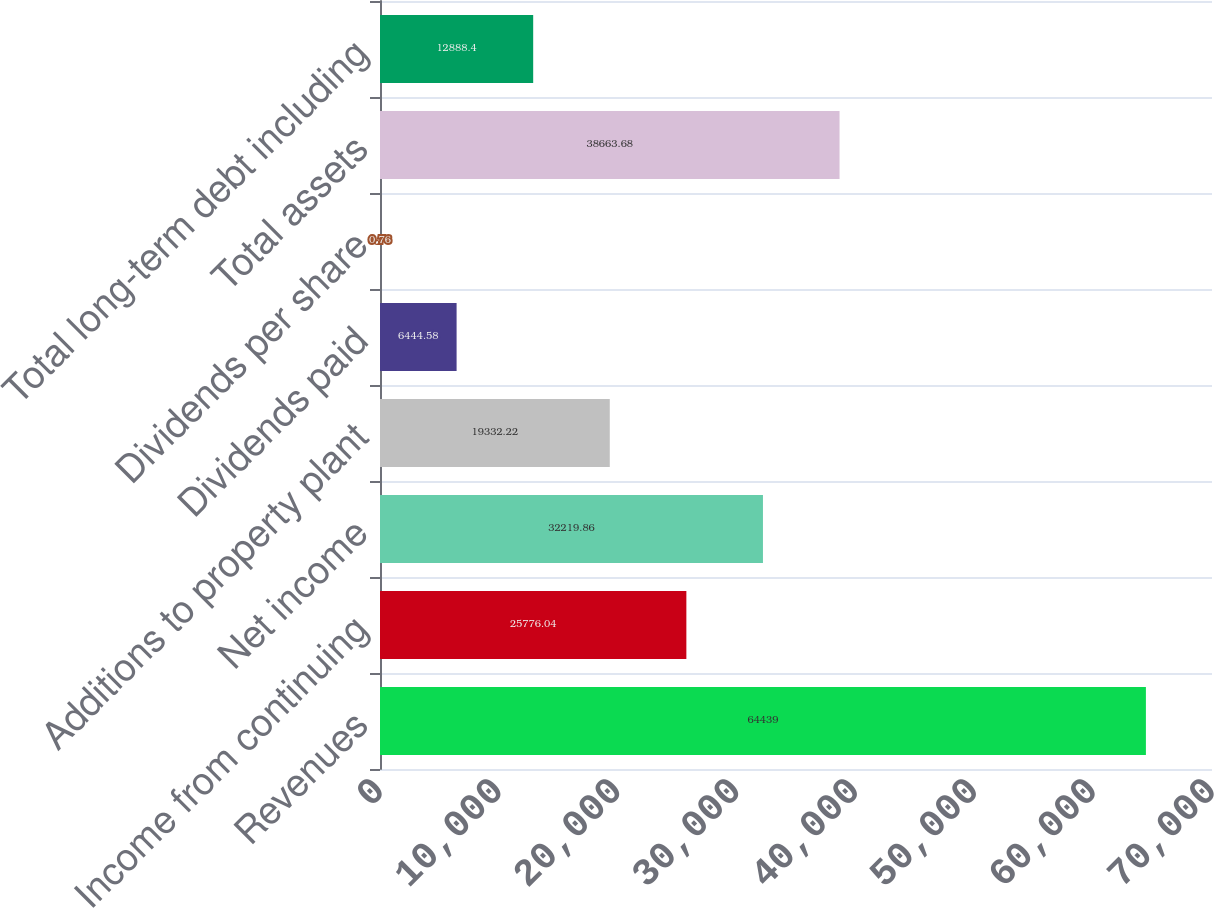Convert chart. <chart><loc_0><loc_0><loc_500><loc_500><bar_chart><fcel>Revenues<fcel>Income from continuing<fcel>Net income<fcel>Additions to property plant<fcel>Dividends paid<fcel>Dividends per share<fcel>Total assets<fcel>Total long-term debt including<nl><fcel>64439<fcel>25776<fcel>32219.9<fcel>19332.2<fcel>6444.58<fcel>0.76<fcel>38663.7<fcel>12888.4<nl></chart> 